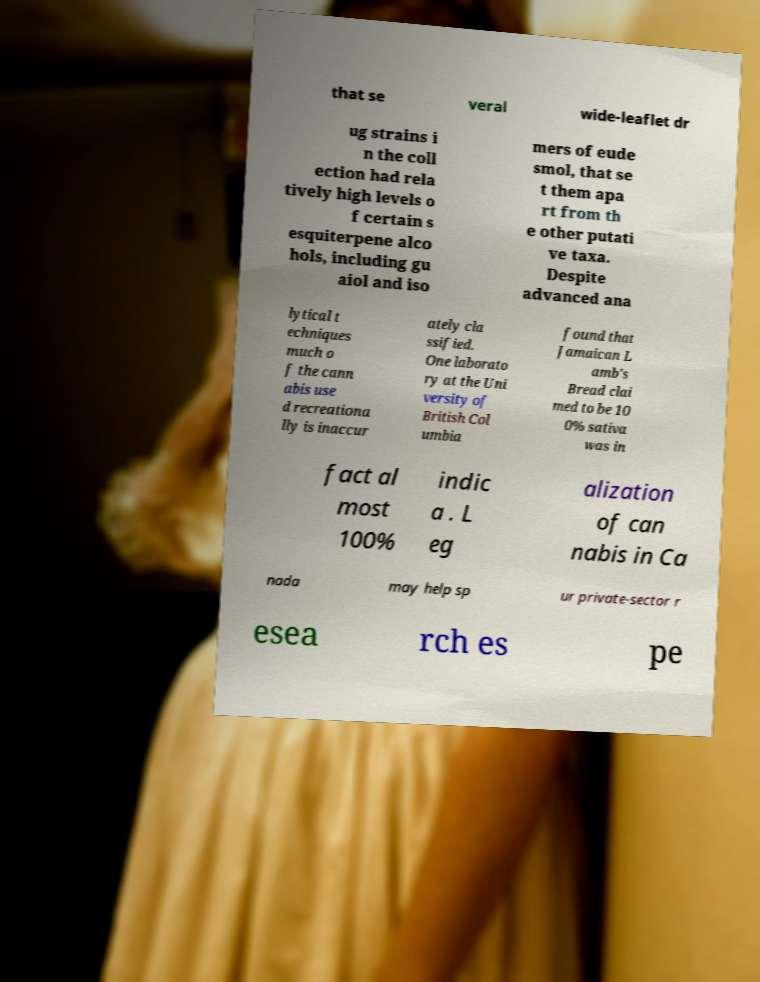Can you accurately transcribe the text from the provided image for me? that se veral wide-leaflet dr ug strains i n the coll ection had rela tively high levels o f certain s esquiterpene alco hols, including gu aiol and iso mers of eude smol, that se t them apa rt from th e other putati ve taxa. Despite advanced ana lytical t echniques much o f the cann abis use d recreationa lly is inaccur ately cla ssified. One laborato ry at the Uni versity of British Col umbia found that Jamaican L amb's Bread clai med to be 10 0% sativa was in fact al most 100% indic a . L eg alization of can nabis in Ca nada may help sp ur private-sector r esea rch es pe 